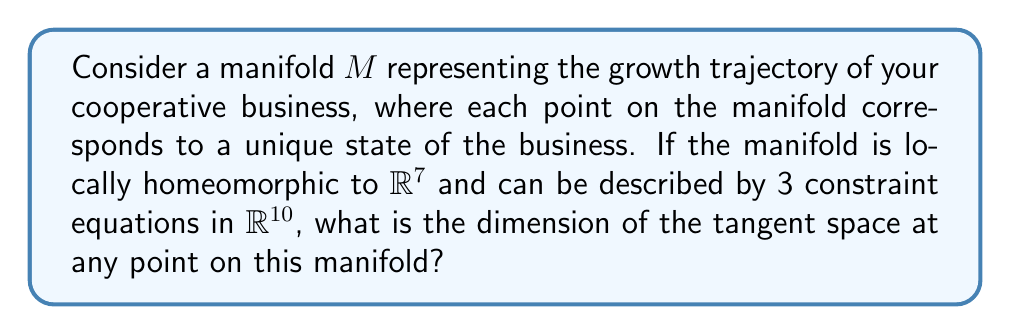Help me with this question. To solve this problem, we'll follow these steps:

1) First, recall that the dimension of a manifold is equal to the dimension of its tangent space at any point.

2) The manifold $M$ is locally homeomorphic to $\mathbb{R}^7$. This means that locally, the manifold "looks like" a 7-dimensional Euclidean space.

3) However, we're given additional information about constraint equations. The manifold is described by 3 constraint equations in $\mathbb{R}^{10}$.

4) In general, if we have a manifold described by $k$ constraint equations in $\mathbb{R}^n$, the dimension of the manifold is $n - k$.

5) In this case:
   $n = 10$ (the ambient space is $\mathbb{R}^{10}$)
   $k = 3$ (there are 3 constraint equations)

6) Therefore, the dimension of the manifold is:

   $$\dim(M) = n - k = 10 - 3 = 7$$

7) This matches with the fact that $M$ is locally homeomorphic to $\mathbb{R}^7$.

8) Since the dimension of the tangent space at any point is equal to the dimension of the manifold, we conclude that the dimension of the tangent space is also 7.
Answer: 7 